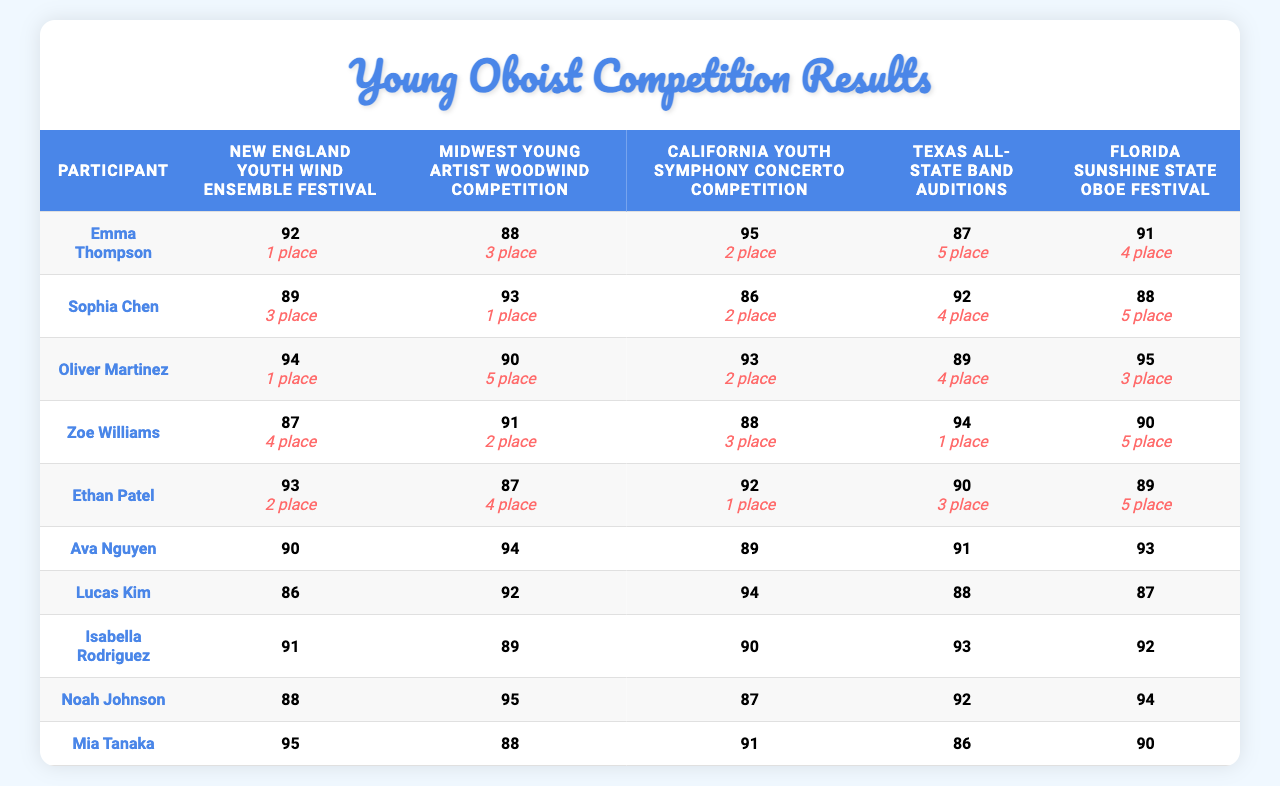What are the scores of Emma Thompson in the festivals? Checking the first row of the table under scores, Emma Thompson received scores of 92, 88, 95, 87, and 91 in different festivals.
Answer: 92, 88, 95, 87, 91 Who placed first in the California Youth Symphony Concerto Competition? Looking at the placements for that festival, Oliver Martinez has the number 1 next to their name, indicating their first place finish.
Answer: Oliver Martinez What is the average score of Mia Tanaka across all festivals? Mia Tanaka's scores are 88, 95, 87, 92, and 94. To find the average, we add these scores (88 + 95 + 87 + 92 + 94 = 456) and divide by the number of scores (5). Thus, the average score is 456/5 = 91.2.
Answer: 91.2 Did Sophia Chen score above 90 in any competition? Reviewing Sophia Chen's scores, which are 89, 93, 86, 92, and 88, she scored above 90 only in the second and fourth festivals (93 and 92, respectively).
Answer: Yes Who had the highest score in the Texas All-State Band Auditions? Checking the scores for that festival, Ava Nguyen received the highest score of 94.
Answer: Ava Nguyen How many participants scored above 90 in the New England Youth Wind Ensemble Festival? Looking at the scores for the New England Youth Wind Ensemble Festival, the scores are 92, 89, 94, 87, and 93. There are four scores above 90 (92, 94, 93).
Answer: 4 Which participant achieved the highest placement overall? The participant with the highest placement overall can be identified by checking placements across all festivals; the least number indicates the best placement. The best placement (1st) was achieved by Emma Thompson and Oliver Martinez.
Answer: Emma Thompson and Oliver Martinez What is the score difference between the highest and lowest scores for Lucas Kim? Lucas Kim's scores are 86, 92, 94, 88, and 87. The highest score is 94 and the lowest score is 86. The score difference is calculated as 94 - 86 = 8.
Answer: 8 Which festival had the lowest average placement score? To find the festival with the lowest average placement, we calculate the average placements for each festival: New England (3.0), Midwest (3.0), California (2.0), Texas (3.6), and Florida (4.0). The average for California is the lowest at 2.0.
Answer: California Youth Symphony Concerto Competition Did Ethan Patel perform better than Mia Tanaka in the Florida Sunshine State Oboe Festival? For the Florida Sunshine State Oboe Festival, Ethan Patel's score is 89 and Mia Tanaka's score is 94. Since 89 is less than 94, Ethan Patel did not perform better.
Answer: No 